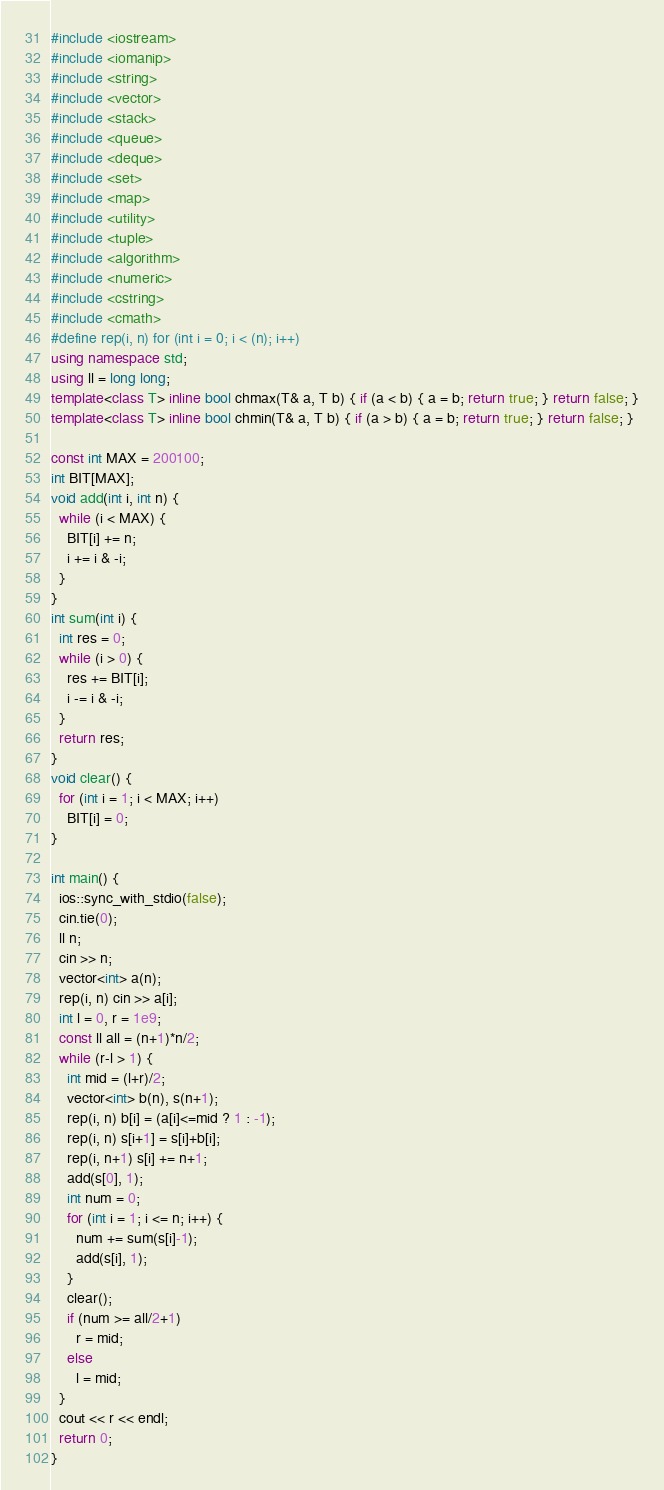<code> <loc_0><loc_0><loc_500><loc_500><_C++_>#include <iostream>
#include <iomanip>
#include <string>
#include <vector>
#include <stack>
#include <queue>
#include <deque>
#include <set>
#include <map>
#include <utility>
#include <tuple>
#include <algorithm>
#include <numeric>
#include <cstring>
#include <cmath>
#define rep(i, n) for (int i = 0; i < (n); i++)
using namespace std;
using ll = long long;
template<class T> inline bool chmax(T& a, T b) { if (a < b) { a = b; return true; } return false; }
template<class T> inline bool chmin(T& a, T b) { if (a > b) { a = b; return true; } return false; }

const int MAX = 200100;
int BIT[MAX];
void add(int i, int n) {
  while (i < MAX) {
    BIT[i] += n;
    i += i & -i;
  }
}
int sum(int i) {
  int res = 0;
  while (i > 0) {
    res += BIT[i];
    i -= i & -i;
  }
  return res;
}
void clear() {
  for (int i = 1; i < MAX; i++)
    BIT[i] = 0;
}

int main() {
  ios::sync_with_stdio(false);
  cin.tie(0);
  ll n;
  cin >> n;
  vector<int> a(n);
  rep(i, n) cin >> a[i];
  int l = 0, r = 1e9;
  const ll all = (n+1)*n/2;
  while (r-l > 1) {
    int mid = (l+r)/2;
    vector<int> b(n), s(n+1);
    rep(i, n) b[i] = (a[i]<=mid ? 1 : -1);
    rep(i, n) s[i+1] = s[i]+b[i];
    rep(i, n+1) s[i] += n+1;
    add(s[0], 1);
    int num = 0;
    for (int i = 1; i <= n; i++) {
      num += sum(s[i]-1);
      add(s[i], 1);
    }
    clear();
    if (num >= all/2+1)
      r = mid;
    else
      l = mid;
  }
  cout << r << endl;
  return 0;
}</code> 